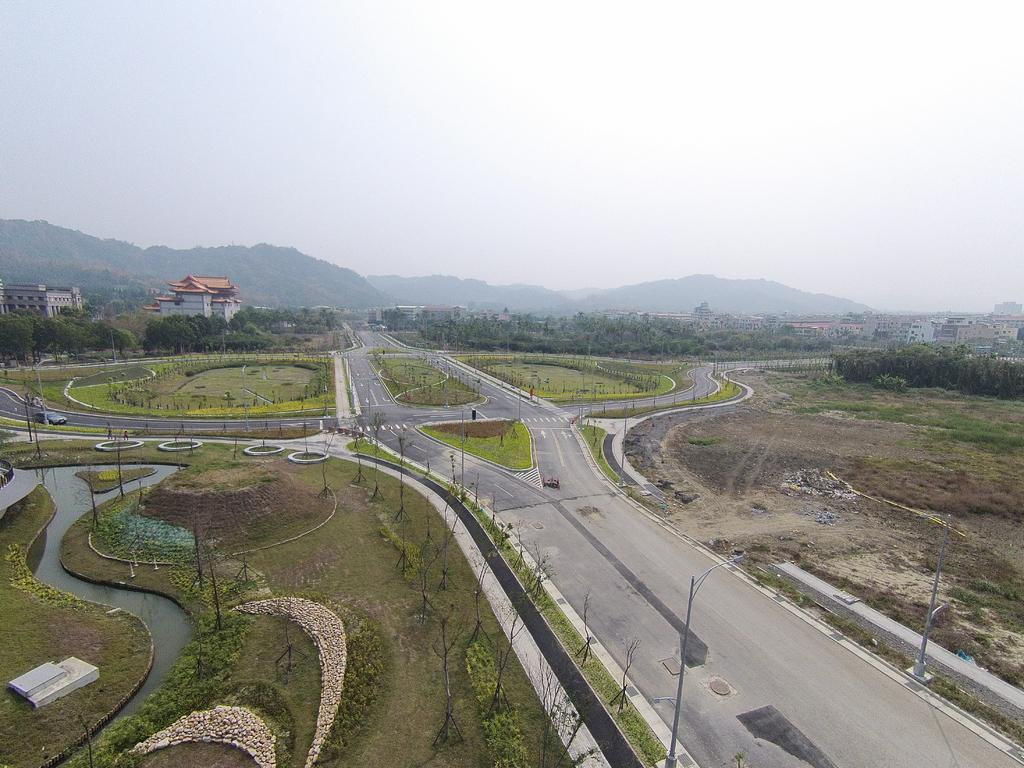What type of surface can be seen in the image? There is a road in the image. What natural elements are visible in the image? Trees and water are visible in the image. What man-made structures can be seen in the image? Poles and buildings are visible in the image. What is the background of the image like? Mountains and the sky are visible in the background of the image. Can you describe the vehicle present in the image? A vehicle is present in the image, but its specific type or features are not mentioned in the facts. What other objects are present in the image? There are objects in the image, but their specific nature is not mentioned in the facts. What type of feeling can be seen on the faces of the trees in the image? Trees do not have faces or feelings, so this question cannot be answered based on the facts provided. What color is the blood on the poles in the image? There is no mention of blood in the image, so this question cannot be answered based on the facts provided. 